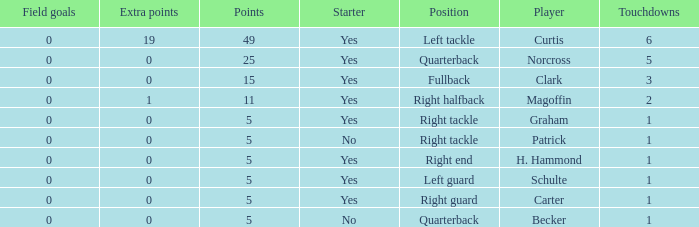Name the most touchdowns for becker  1.0. 